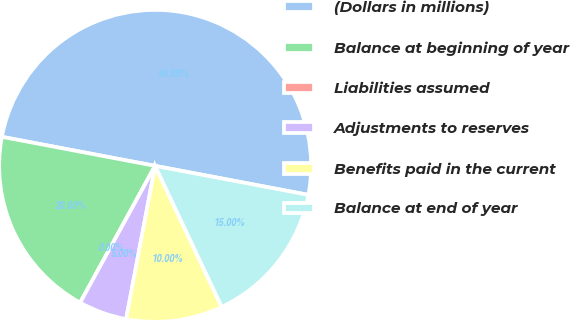Convert chart. <chart><loc_0><loc_0><loc_500><loc_500><pie_chart><fcel>(Dollars in millions)<fcel>Balance at beginning of year<fcel>Liabilities assumed<fcel>Adjustments to reserves<fcel>Benefits paid in the current<fcel>Balance at end of year<nl><fcel>49.99%<fcel>20.0%<fcel>0.0%<fcel>5.0%<fcel>10.0%<fcel>15.0%<nl></chart> 